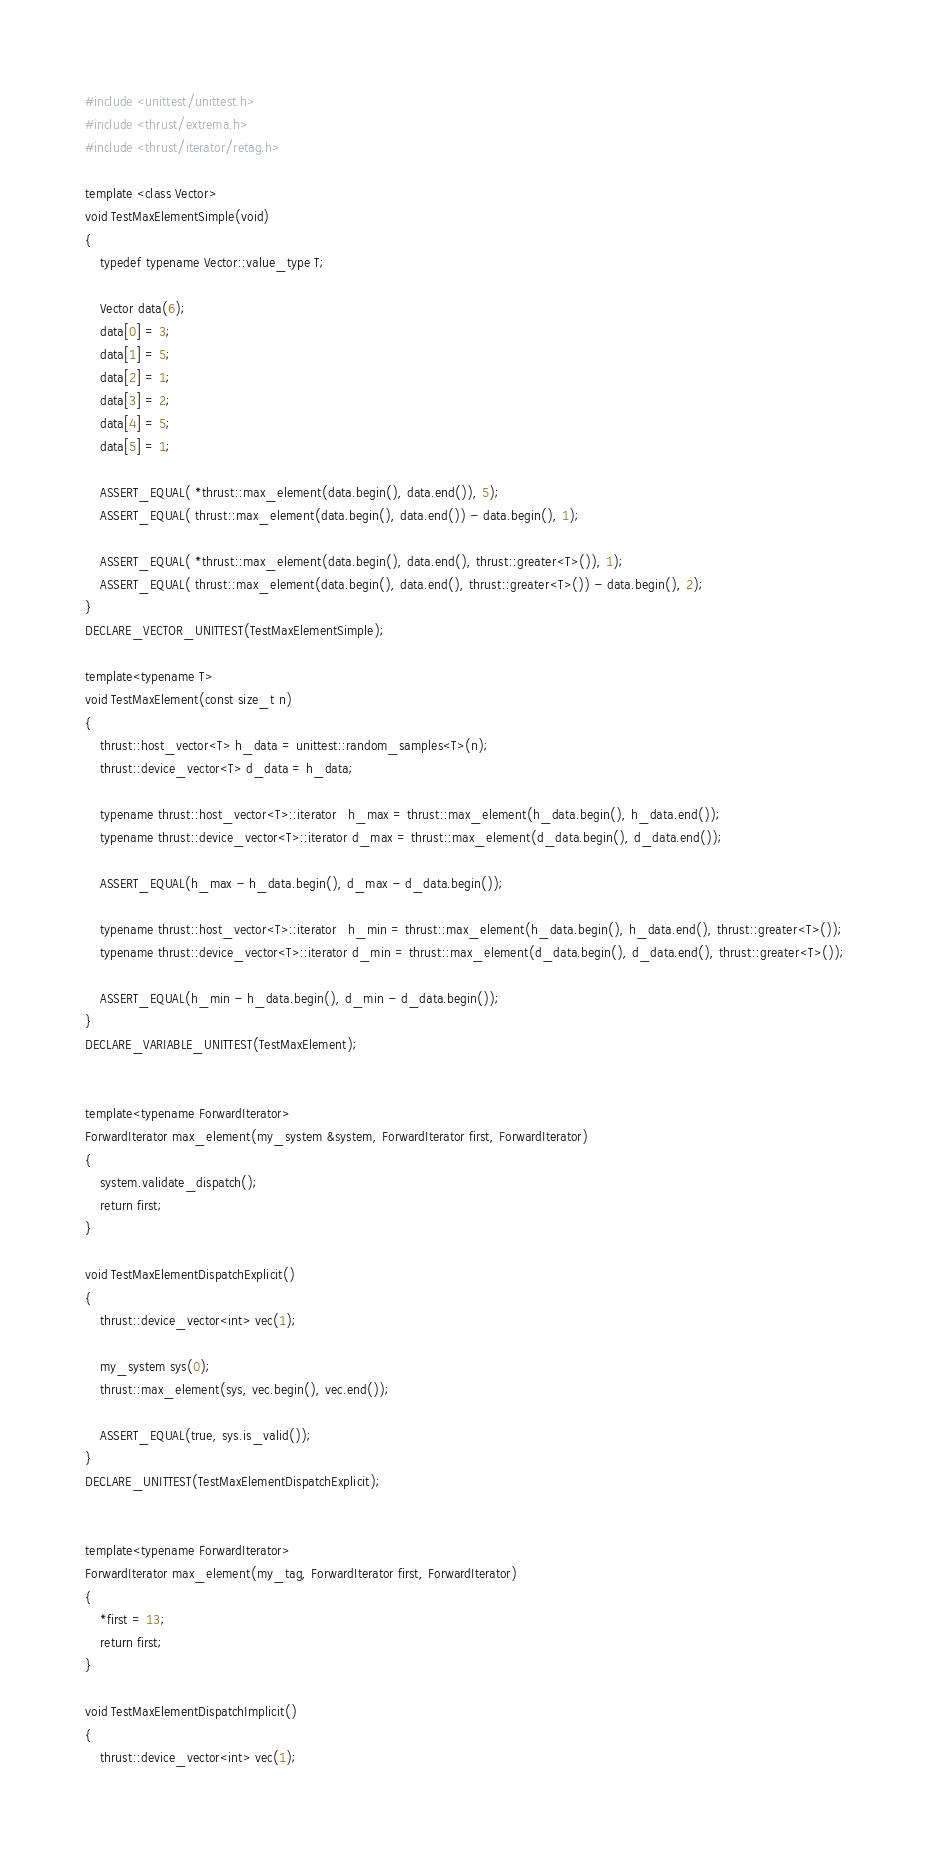<code> <loc_0><loc_0><loc_500><loc_500><_Cuda_>#include <unittest/unittest.h>
#include <thrust/extrema.h>
#include <thrust/iterator/retag.h>

template <class Vector>
void TestMaxElementSimple(void)
{
    typedef typename Vector::value_type T;

    Vector data(6);
    data[0] = 3;
    data[1] = 5;
    data[2] = 1;
    data[3] = 2;
    data[4] = 5;
    data[5] = 1;

    ASSERT_EQUAL( *thrust::max_element(data.begin(), data.end()), 5);
    ASSERT_EQUAL( thrust::max_element(data.begin(), data.end()) - data.begin(), 1);
    
    ASSERT_EQUAL( *thrust::max_element(data.begin(), data.end(), thrust::greater<T>()), 1);
    ASSERT_EQUAL( thrust::max_element(data.begin(), data.end(), thrust::greater<T>()) - data.begin(), 2);
}
DECLARE_VECTOR_UNITTEST(TestMaxElementSimple);

template<typename T>
void TestMaxElement(const size_t n)
{
    thrust::host_vector<T> h_data = unittest::random_samples<T>(n);
    thrust::device_vector<T> d_data = h_data;

    typename thrust::host_vector<T>::iterator   h_max = thrust::max_element(h_data.begin(), h_data.end());
    typename thrust::device_vector<T>::iterator d_max = thrust::max_element(d_data.begin(), d_data.end());

    ASSERT_EQUAL(h_max - h_data.begin(), d_max - d_data.begin());
    
    typename thrust::host_vector<T>::iterator   h_min = thrust::max_element(h_data.begin(), h_data.end(), thrust::greater<T>());
    typename thrust::device_vector<T>::iterator d_min = thrust::max_element(d_data.begin(), d_data.end(), thrust::greater<T>());

    ASSERT_EQUAL(h_min - h_data.begin(), d_min - d_data.begin());
}
DECLARE_VARIABLE_UNITTEST(TestMaxElement);


template<typename ForwardIterator>
ForwardIterator max_element(my_system &system, ForwardIterator first, ForwardIterator)
{
    system.validate_dispatch();
    return first;
}

void TestMaxElementDispatchExplicit()
{
    thrust::device_vector<int> vec(1);

    my_system sys(0);
    thrust::max_element(sys, vec.begin(), vec.end());

    ASSERT_EQUAL(true, sys.is_valid());
}
DECLARE_UNITTEST(TestMaxElementDispatchExplicit);


template<typename ForwardIterator>
ForwardIterator max_element(my_tag, ForwardIterator first, ForwardIterator)
{
    *first = 13;
    return first;
}

void TestMaxElementDispatchImplicit()
{
    thrust::device_vector<int> vec(1);
</code> 